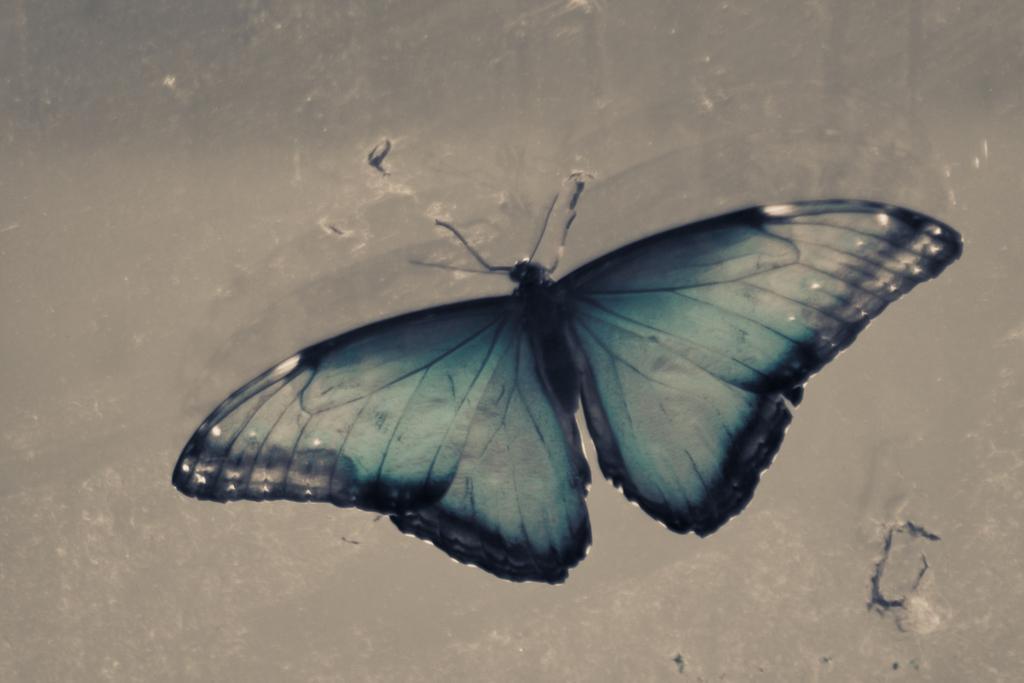How would you summarize this image in a sentence or two? In this image there is a butterfly in middle of this image and there is a wall in the background. 